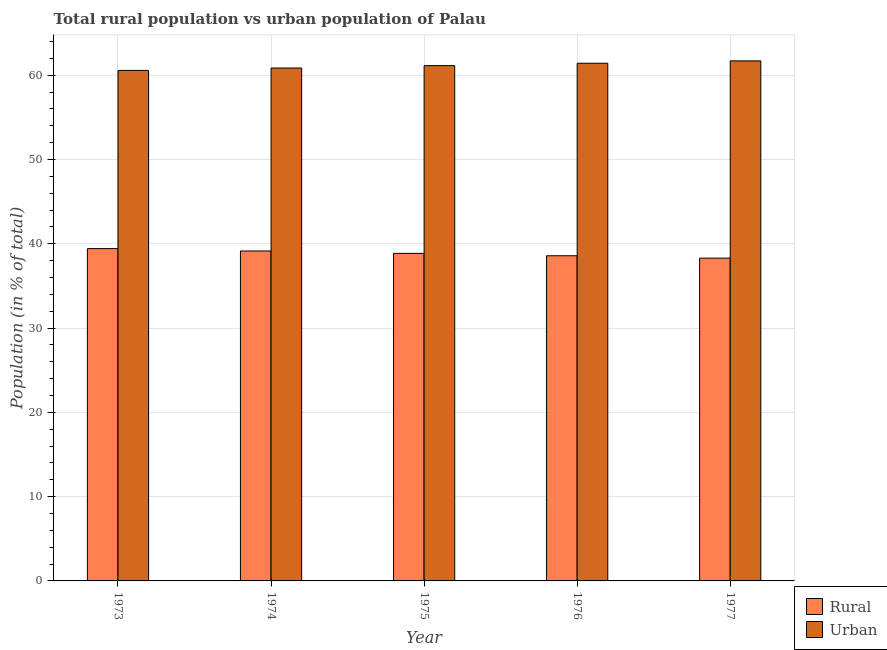Are the number of bars per tick equal to the number of legend labels?
Give a very brief answer. Yes. How many bars are there on the 5th tick from the left?
Provide a succinct answer. 2. How many bars are there on the 1st tick from the right?
Your answer should be compact. 2. What is the label of the 4th group of bars from the left?
Offer a terse response. 1976. What is the rural population in 1976?
Your answer should be very brief. 38.58. Across all years, what is the maximum rural population?
Keep it short and to the point. 39.43. Across all years, what is the minimum urban population?
Your answer should be compact. 60.57. In which year was the rural population minimum?
Ensure brevity in your answer.  1977. What is the total rural population in the graph?
Offer a very short reply. 194.31. What is the difference between the rural population in 1973 and that in 1975?
Provide a succinct answer. 0.57. What is the difference between the rural population in 1975 and the urban population in 1973?
Keep it short and to the point. -0.57. What is the average urban population per year?
Your response must be concise. 61.14. In the year 1974, what is the difference between the rural population and urban population?
Ensure brevity in your answer.  0. What is the ratio of the urban population in 1974 to that in 1976?
Offer a terse response. 0.99. Is the urban population in 1973 less than that in 1974?
Give a very brief answer. Yes. What is the difference between the highest and the second highest urban population?
Keep it short and to the point. 0.28. What is the difference between the highest and the lowest urban population?
Offer a terse response. 1.13. In how many years, is the rural population greater than the average rural population taken over all years?
Provide a short and direct response. 2. Is the sum of the urban population in 1973 and 1974 greater than the maximum rural population across all years?
Keep it short and to the point. Yes. What does the 1st bar from the left in 1975 represents?
Ensure brevity in your answer.  Rural. What does the 1st bar from the right in 1975 represents?
Give a very brief answer. Urban. How many years are there in the graph?
Your answer should be compact. 5. What is the difference between two consecutive major ticks on the Y-axis?
Make the answer very short. 10. Does the graph contain any zero values?
Keep it short and to the point. No. Does the graph contain grids?
Give a very brief answer. Yes. How many legend labels are there?
Your answer should be compact. 2. What is the title of the graph?
Your answer should be very brief. Total rural population vs urban population of Palau. Does "Nitrous oxide emissions" appear as one of the legend labels in the graph?
Offer a terse response. No. What is the label or title of the X-axis?
Provide a succinct answer. Year. What is the label or title of the Y-axis?
Offer a terse response. Population (in % of total). What is the Population (in % of total) in Rural in 1973?
Your answer should be compact. 39.43. What is the Population (in % of total) in Urban in 1973?
Provide a short and direct response. 60.57. What is the Population (in % of total) in Rural in 1974?
Give a very brief answer. 39.15. What is the Population (in % of total) in Urban in 1974?
Ensure brevity in your answer.  60.85. What is the Population (in % of total) of Rural in 1975?
Offer a terse response. 38.86. What is the Population (in % of total) of Urban in 1975?
Your answer should be very brief. 61.14. What is the Population (in % of total) of Rural in 1976?
Your answer should be compact. 38.58. What is the Population (in % of total) of Urban in 1976?
Offer a very short reply. 61.42. What is the Population (in % of total) in Rural in 1977?
Keep it short and to the point. 38.3. What is the Population (in % of total) of Urban in 1977?
Your answer should be very brief. 61.7. Across all years, what is the maximum Population (in % of total) in Rural?
Provide a short and direct response. 39.43. Across all years, what is the maximum Population (in % of total) in Urban?
Your answer should be compact. 61.7. Across all years, what is the minimum Population (in % of total) in Rural?
Your answer should be compact. 38.3. Across all years, what is the minimum Population (in % of total) of Urban?
Make the answer very short. 60.57. What is the total Population (in % of total) in Rural in the graph?
Provide a succinct answer. 194.31. What is the total Population (in % of total) in Urban in the graph?
Keep it short and to the point. 305.69. What is the difference between the Population (in % of total) in Rural in 1973 and that in 1974?
Keep it short and to the point. 0.28. What is the difference between the Population (in % of total) of Urban in 1973 and that in 1974?
Make the answer very short. -0.28. What is the difference between the Population (in % of total) of Rural in 1973 and that in 1975?
Your answer should be compact. 0.57. What is the difference between the Population (in % of total) of Urban in 1973 and that in 1975?
Give a very brief answer. -0.57. What is the difference between the Population (in % of total) of Urban in 1973 and that in 1976?
Provide a short and direct response. -0.85. What is the difference between the Population (in % of total) of Rural in 1973 and that in 1977?
Provide a succinct answer. 1.13. What is the difference between the Population (in % of total) of Urban in 1973 and that in 1977?
Your response must be concise. -1.13. What is the difference between the Population (in % of total) in Rural in 1974 and that in 1975?
Provide a short and direct response. 0.28. What is the difference between the Population (in % of total) in Urban in 1974 and that in 1975?
Your response must be concise. -0.28. What is the difference between the Population (in % of total) of Rural in 1974 and that in 1976?
Provide a short and direct response. 0.57. What is the difference between the Population (in % of total) in Urban in 1974 and that in 1976?
Provide a short and direct response. -0.57. What is the difference between the Population (in % of total) of Rural in 1974 and that in 1977?
Ensure brevity in your answer.  0.85. What is the difference between the Population (in % of total) of Urban in 1974 and that in 1977?
Make the answer very short. -0.85. What is the difference between the Population (in % of total) of Rural in 1975 and that in 1976?
Keep it short and to the point. 0.28. What is the difference between the Population (in % of total) in Urban in 1975 and that in 1976?
Your response must be concise. -0.28. What is the difference between the Population (in % of total) in Rural in 1975 and that in 1977?
Provide a succinct answer. 0.56. What is the difference between the Population (in % of total) in Urban in 1975 and that in 1977?
Your answer should be very brief. -0.56. What is the difference between the Population (in % of total) in Rural in 1976 and that in 1977?
Provide a short and direct response. 0.28. What is the difference between the Population (in % of total) in Urban in 1976 and that in 1977?
Your answer should be compact. -0.28. What is the difference between the Population (in % of total) in Rural in 1973 and the Population (in % of total) in Urban in 1974?
Your answer should be very brief. -21.43. What is the difference between the Population (in % of total) of Rural in 1973 and the Population (in % of total) of Urban in 1975?
Keep it short and to the point. -21.71. What is the difference between the Population (in % of total) of Rural in 1973 and the Population (in % of total) of Urban in 1976?
Provide a short and direct response. -21.99. What is the difference between the Population (in % of total) of Rural in 1973 and the Population (in % of total) of Urban in 1977?
Keep it short and to the point. -22.27. What is the difference between the Population (in % of total) of Rural in 1974 and the Population (in % of total) of Urban in 1975?
Offer a terse response. -21.99. What is the difference between the Population (in % of total) of Rural in 1974 and the Population (in % of total) of Urban in 1976?
Provide a short and direct response. -22.28. What is the difference between the Population (in % of total) of Rural in 1974 and the Population (in % of total) of Urban in 1977?
Offer a very short reply. -22.56. What is the difference between the Population (in % of total) of Rural in 1975 and the Population (in % of total) of Urban in 1976?
Make the answer very short. -22.56. What is the difference between the Population (in % of total) in Rural in 1975 and the Population (in % of total) in Urban in 1977?
Ensure brevity in your answer.  -22.84. What is the difference between the Population (in % of total) of Rural in 1976 and the Population (in % of total) of Urban in 1977?
Provide a short and direct response. -23.12. What is the average Population (in % of total) of Rural per year?
Give a very brief answer. 38.86. What is the average Population (in % of total) in Urban per year?
Keep it short and to the point. 61.14. In the year 1973, what is the difference between the Population (in % of total) of Rural and Population (in % of total) of Urban?
Make the answer very short. -21.14. In the year 1974, what is the difference between the Population (in % of total) in Rural and Population (in % of total) in Urban?
Offer a very short reply. -21.71. In the year 1975, what is the difference between the Population (in % of total) of Rural and Population (in % of total) of Urban?
Your response must be concise. -22.28. In the year 1976, what is the difference between the Population (in % of total) of Rural and Population (in % of total) of Urban?
Offer a very short reply. -22.84. In the year 1977, what is the difference between the Population (in % of total) of Rural and Population (in % of total) of Urban?
Make the answer very short. -23.4. What is the ratio of the Population (in % of total) in Rural in 1973 to that in 1974?
Make the answer very short. 1.01. What is the ratio of the Population (in % of total) of Rural in 1973 to that in 1975?
Keep it short and to the point. 1.01. What is the ratio of the Population (in % of total) of Urban in 1973 to that in 1975?
Provide a short and direct response. 0.99. What is the ratio of the Population (in % of total) of Urban in 1973 to that in 1976?
Provide a succinct answer. 0.99. What is the ratio of the Population (in % of total) in Rural in 1973 to that in 1977?
Give a very brief answer. 1.03. What is the ratio of the Population (in % of total) in Urban in 1973 to that in 1977?
Offer a terse response. 0.98. What is the ratio of the Population (in % of total) of Rural in 1974 to that in 1975?
Make the answer very short. 1.01. What is the ratio of the Population (in % of total) of Rural in 1974 to that in 1976?
Your answer should be compact. 1.01. What is the ratio of the Population (in % of total) in Rural in 1974 to that in 1977?
Your answer should be very brief. 1.02. What is the ratio of the Population (in % of total) of Urban in 1974 to that in 1977?
Provide a short and direct response. 0.99. What is the ratio of the Population (in % of total) in Rural in 1975 to that in 1976?
Provide a succinct answer. 1.01. What is the ratio of the Population (in % of total) of Rural in 1975 to that in 1977?
Give a very brief answer. 1.01. What is the ratio of the Population (in % of total) in Urban in 1975 to that in 1977?
Offer a very short reply. 0.99. What is the ratio of the Population (in % of total) of Rural in 1976 to that in 1977?
Provide a short and direct response. 1.01. What is the difference between the highest and the second highest Population (in % of total) in Rural?
Your answer should be very brief. 0.28. What is the difference between the highest and the second highest Population (in % of total) in Urban?
Ensure brevity in your answer.  0.28. What is the difference between the highest and the lowest Population (in % of total) in Rural?
Offer a very short reply. 1.13. What is the difference between the highest and the lowest Population (in % of total) in Urban?
Offer a terse response. 1.13. 